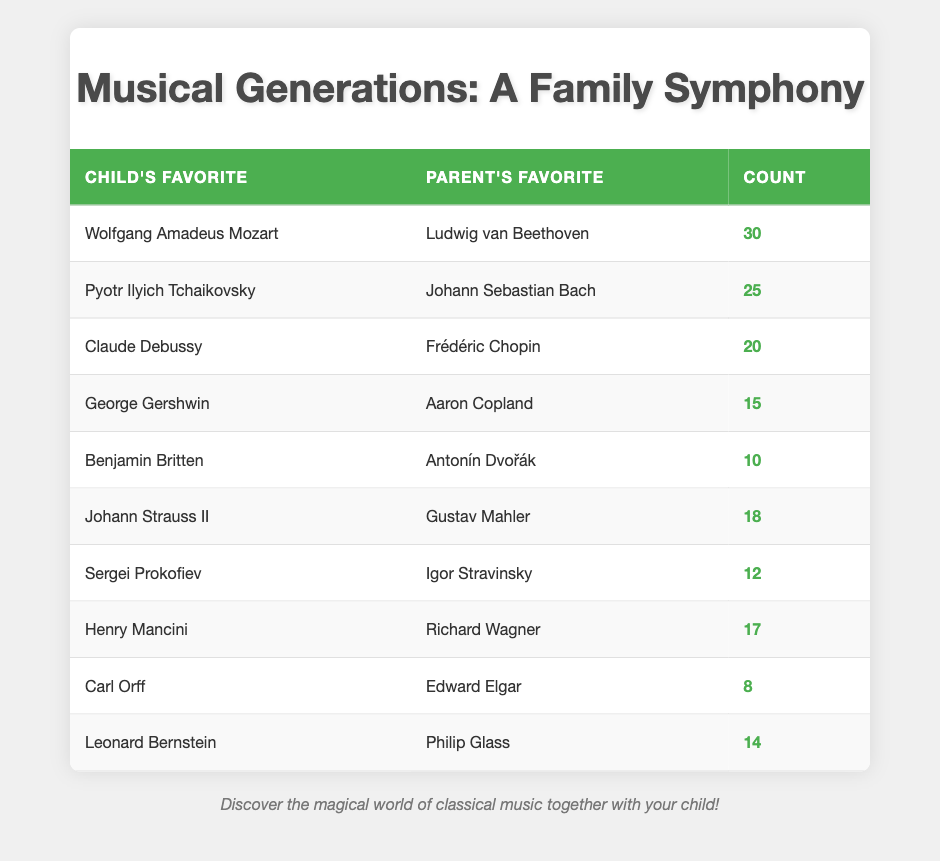What is the favorite composer of the highest number of children? Looking at the counts in the table, Wolfgang Amadeus Mozart is the favorite of 30 children, which is the highest number displayed.
Answer: Wolfgang Amadeus Mozart How many children prefer Claude Debussy? The table shows that 20 children have listed Claude Debussy as their favorite composer.
Answer: 20 Which composer has the lowest number of votes from children? By reviewing the counts, Carl Orff has the lowest count of 8, indicating he is the least favorite among the children.
Answer: Carl Orff What is the total count of children who favor Tchaikovsky and Prokofiev combined? To find this total, we add the counts for Tchaikovsky (25) and Prokofiev (12), resulting in 25 + 12 = 37.
Answer: 37 Is it true that more children prefer Johann Strauss II than Benjamin Britten? Looking at the counts, Johann Strauss II has 18 votes, while Benjamin Britten has 10 votes; thus, it is true that more children favor Strauss II.
Answer: Yes Which parent's favorite composer has the highest count of children liking them? The highest count under parents' favorites corresponds to Ludwig van Beethoven, with a total of 30 children favoring Mozart, whose parent favorite is Beethoven, leading to this count.
Answer: Ludwig van Beethoven What is the combined total of children who favor the two parents' favorite composers: Aaron Copland and Frédéric Chopin? We can find this total by adding the two counts: Aaron Copland (15) and Frédéric Chopin (20), giving us 15 + 20 = 35.
Answer: 35 Do more children prefer Henry Mancini than children who prefer George Gershwin? Henry Mancini has 17 votes, while George Gershwin has 15 votes, so it is true that more children prefer Mancini.
Answer: Yes Which child favorite composer has the closest number of votes to that of their parent favorite composer? The pair with the closest numbers are George Gershwin (15) and his parent favorite Aaron Copland (15), both having the same count of 15.
Answer: George Gershwin and Aaron Copland 